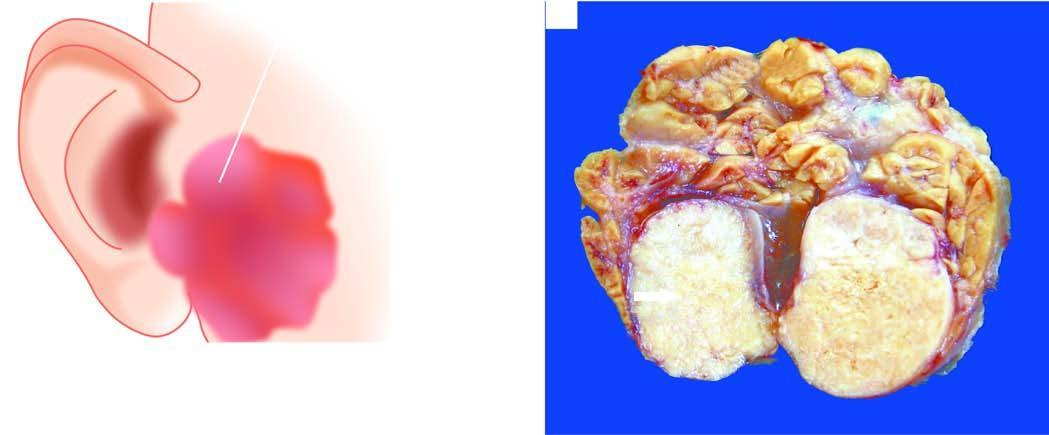does these cases show lobules of grey-white circumscribed tumour having semitranslucent parenchyma?
Answer the question using a single word or phrase. No 